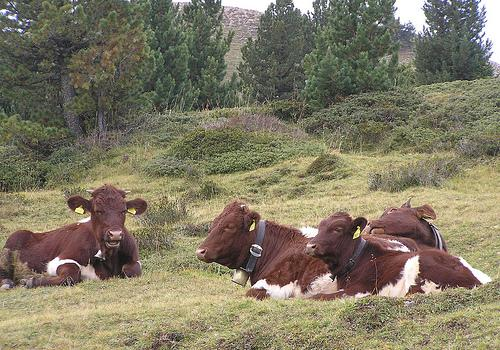Question: where was the picture taken?
Choices:
A. Beach.
B. In a desert.
C. On a sidewalk.
D. A grassy knoll.
Answer with the letter. Answer: D Question: what color are the cows?
Choices:
A. Black and white.
B. Brown.
C. White.
D. Brown and white.
Answer with the letter. Answer: D Question: what is behind the cows?
Choices:
A. Mountains.
B. A lake.
C. A barn.
D. Trees.
Answer with the letter. Answer: D Question: where are the trees?
Choices:
A. Behind the cows.
B. Behind the horses.
C. To the right of the cows.
D. To the left of the cows.
Answer with the letter. Answer: A Question: when was the picture taken?
Choices:
A. Nighttime.
B. While is was snowing.
C. While is was raining.
D. Daytime.
Answer with the letter. Answer: D Question: what are the cows on?
Choices:
A. Dirt.
B. Grass.
C. Muddy ground.
D. Pavement.
Answer with the letter. Answer: B Question: how many cows are there?
Choices:
A. 4.
B. 5.
C. 6.
D. 7.
Answer with the letter. Answer: A 